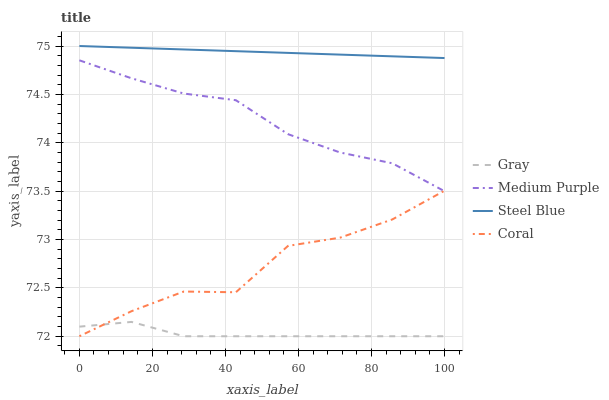Does Gray have the minimum area under the curve?
Answer yes or no. Yes. Does Steel Blue have the maximum area under the curve?
Answer yes or no. Yes. Does Coral have the minimum area under the curve?
Answer yes or no. No. Does Coral have the maximum area under the curve?
Answer yes or no. No. Is Steel Blue the smoothest?
Answer yes or no. Yes. Is Coral the roughest?
Answer yes or no. Yes. Is Gray the smoothest?
Answer yes or no. No. Is Gray the roughest?
Answer yes or no. No. Does Steel Blue have the lowest value?
Answer yes or no. No. Does Steel Blue have the highest value?
Answer yes or no. Yes. Does Coral have the highest value?
Answer yes or no. No. Is Gray less than Steel Blue?
Answer yes or no. Yes. Is Steel Blue greater than Medium Purple?
Answer yes or no. Yes. Does Medium Purple intersect Coral?
Answer yes or no. Yes. Is Medium Purple less than Coral?
Answer yes or no. No. Is Medium Purple greater than Coral?
Answer yes or no. No. Does Gray intersect Steel Blue?
Answer yes or no. No. 